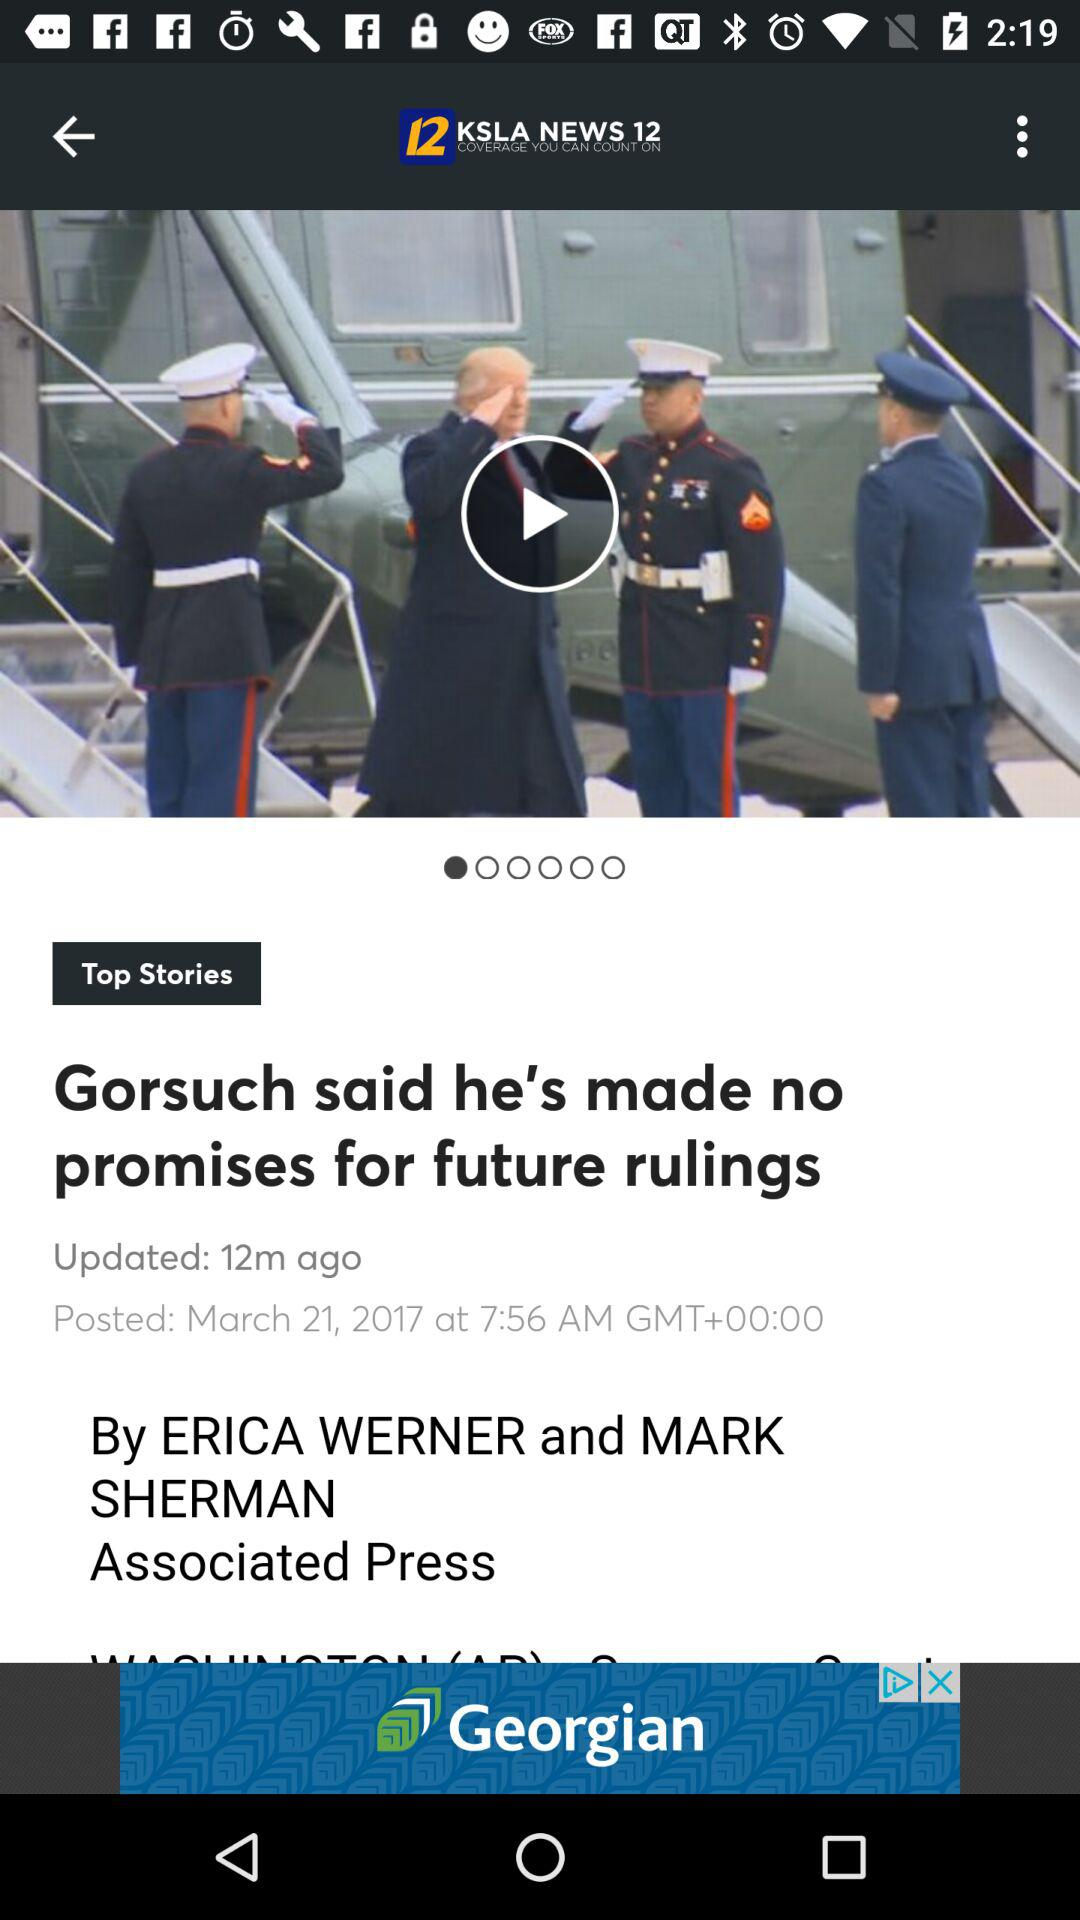Who is the author of Associate Press? The authors of Associate Press are Erica Werner and Mark Sherman. 